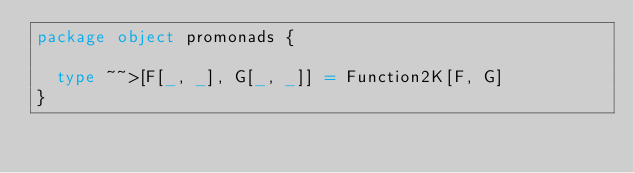Convert code to text. <code><loc_0><loc_0><loc_500><loc_500><_Scala_>package object promonads {

  type ~~>[F[_, _], G[_, _]] = Function2K[F, G]
}
</code> 